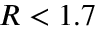<formula> <loc_0><loc_0><loc_500><loc_500>R < 1 . 7</formula> 